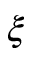<formula> <loc_0><loc_0><loc_500><loc_500>\xi</formula> 